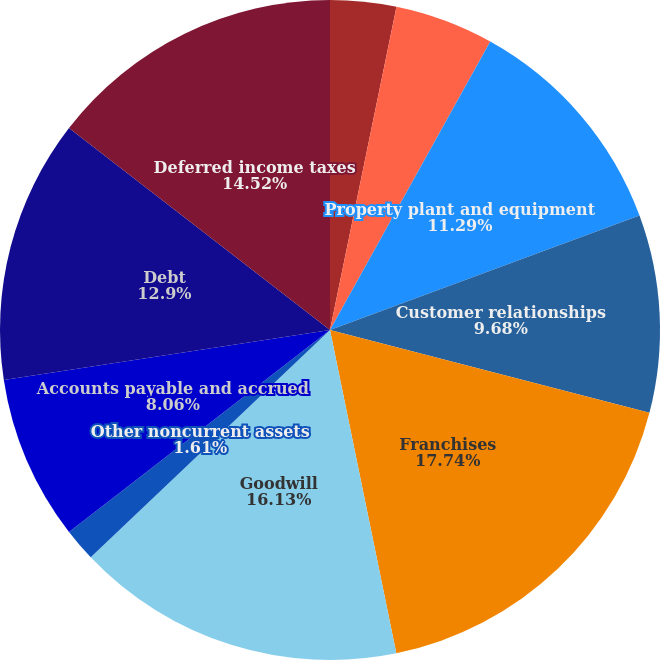Convert chart. <chart><loc_0><loc_0><loc_500><loc_500><pie_chart><fcel>Cash and cash equivalents<fcel>Current assets<fcel>Property plant and equipment<fcel>Customer relationships<fcel>Franchises<fcel>Goodwill<fcel>Other noncurrent assets<fcel>Accounts payable and accrued<fcel>Debt<fcel>Deferred income taxes<nl><fcel>3.23%<fcel>4.84%<fcel>11.29%<fcel>9.68%<fcel>17.74%<fcel>16.13%<fcel>1.61%<fcel>8.06%<fcel>12.9%<fcel>14.52%<nl></chart> 